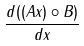<formula> <loc_0><loc_0><loc_500><loc_500>\frac { d ( ( A x ) \circ B ) } { d x }</formula> 